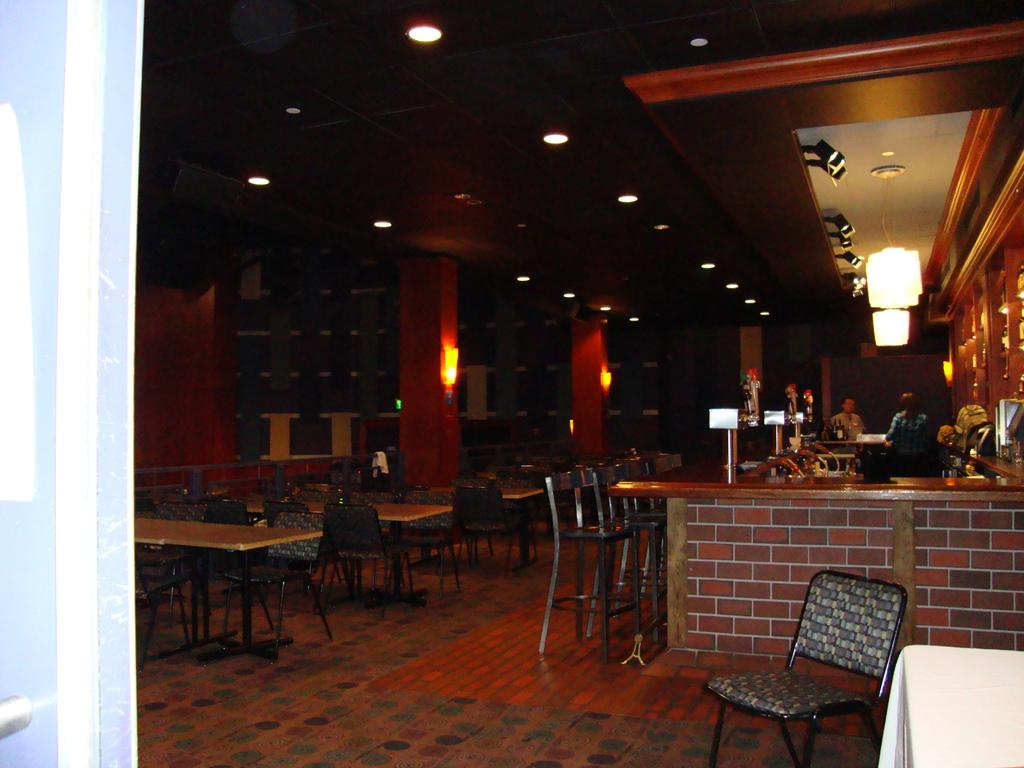What type of furniture is on the floor in the image? There are tables and chairs on the floor in the image. Can you describe the people on the right side of the image? There are two persons on the right side of the image. What is the lighting arrangement in the image? There is a lighting arrangement on the roof in the image. What type of song is being played on the scale in the image? There is no scale or song present in the image; it features tables, chairs, two persons, and a lighting arrangement on the roof. What is the condition of the person on the left side of the image? There is no person on the left side of the image; it only shows two persons on the right side. 